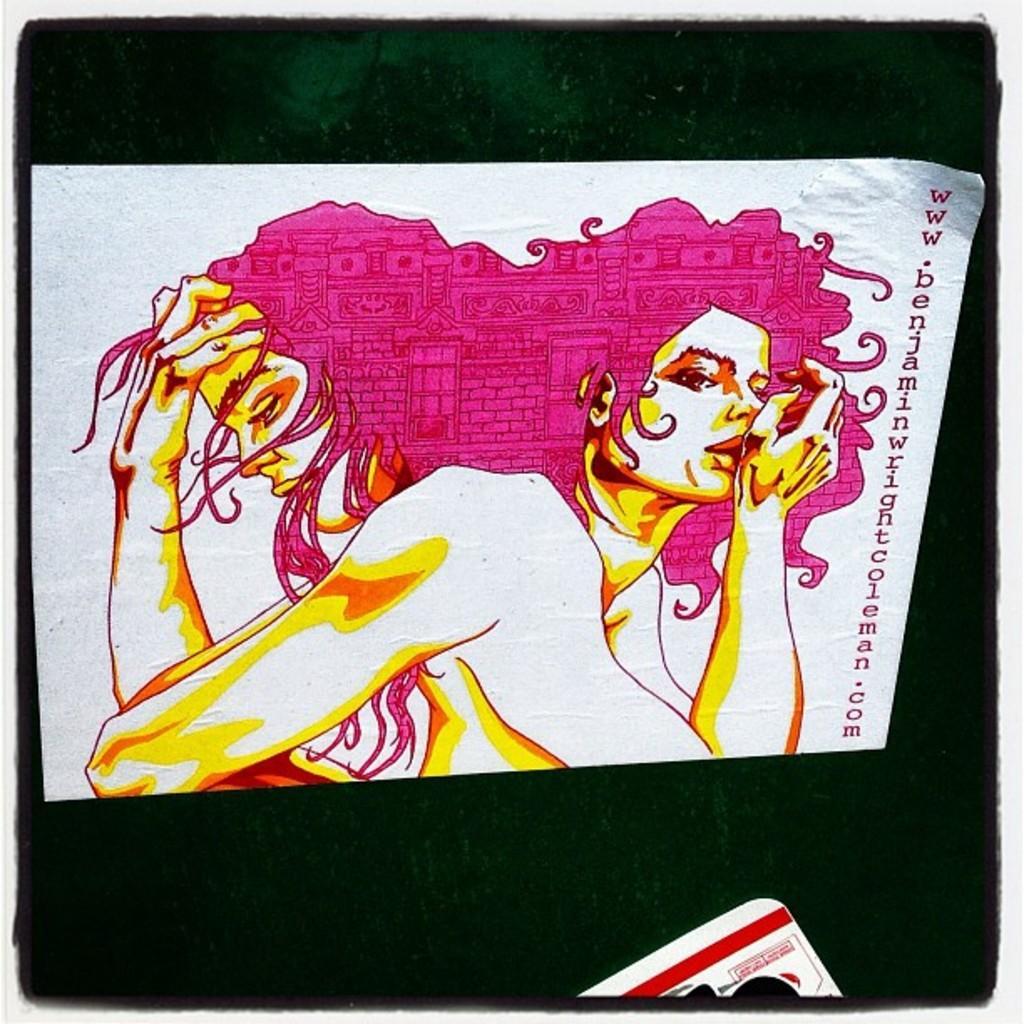In one or two sentences, can you explain what this image depicts? This picture might be a painting on the paper. In the background, we can also see black color. 